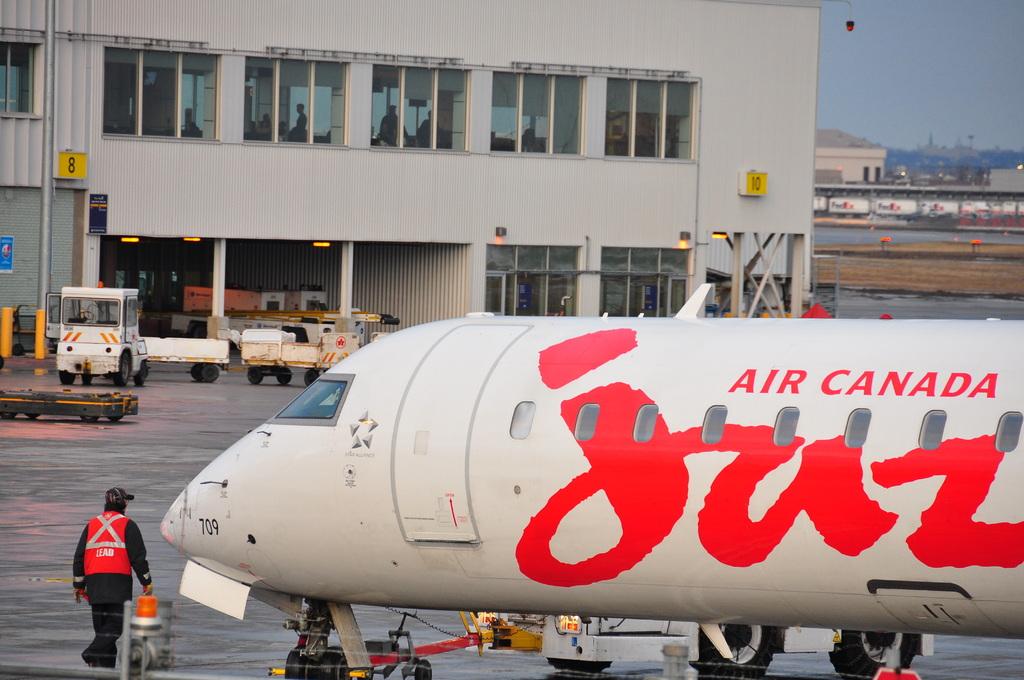What's the name of the airline?
Ensure brevity in your answer.  Air canada. 